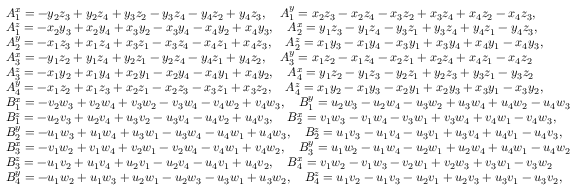Convert formula to latex. <formula><loc_0><loc_0><loc_500><loc_500>\begin{array} { r l } & { A _ { 1 } ^ { x } = - y _ { 2 } z _ { 3 } + y _ { 2 } z _ { 4 } + y _ { 3 } z _ { 2 } - y _ { 3 } z _ { 4 } - y _ { 4 } z _ { 2 } + y _ { 4 } z _ { 3 } , \quad A _ { 1 } ^ { y } = x _ { 2 } z _ { 3 } - x _ { 2 } z _ { 4 } - x _ { 3 } z _ { 2 } + x _ { 3 } z _ { 4 } + x _ { 4 } z _ { 2 } - x _ { 4 } z _ { 3 } , } \\ & { A _ { 1 } ^ { z } = - x _ { 2 } y _ { 3 } + x _ { 2 } y _ { 4 } + x _ { 3 } y _ { 2 } - x _ { 3 } y _ { 4 } - x _ { 4 } y _ { 2 } + x _ { 4 } y _ { 3 } , \quad A _ { 2 } ^ { x } = y _ { 1 } z _ { 3 } - y _ { 1 } z _ { 4 } - y _ { 3 } z _ { 1 } + y _ { 3 } z _ { 4 } + y _ { 4 } z _ { 1 } - y _ { 4 } z _ { 3 } , } \\ & { A _ { 2 } ^ { y } = - x _ { 1 } z _ { 3 } + x _ { 1 } z _ { 4 } + x _ { 3 } z _ { 1 } - x _ { 3 } z _ { 4 } - x _ { 4 } z _ { 1 } + x _ { 4 } z _ { 3 } , \quad A _ { 2 } ^ { z } = x _ { 1 } y _ { 3 } - x _ { 1 } y _ { 4 } - x _ { 3 } y _ { 1 } + x _ { 3 } y _ { 4 } + x _ { 4 } y _ { 1 } - x _ { 4 } y _ { 3 } , } \\ & { A _ { 3 } ^ { x } = - y _ { 1 } z _ { 2 } + y _ { 1 } z _ { 4 } + y _ { 2 } z _ { 1 } - y _ { 2 } z _ { 4 } - y _ { 4 } z _ { 1 } + y _ { 4 } z _ { 2 } , \quad A _ { 3 } ^ { y } = x _ { 1 } z _ { 2 } - x _ { 1 } z _ { 4 } - x _ { 2 } z _ { 1 } + x _ { 2 } z _ { 4 } + x _ { 4 } z _ { 1 } - x _ { 4 } z _ { 2 } } \\ & { A _ { 3 } ^ { z } = - x _ { 1 } y _ { 2 } + x _ { 1 } y _ { 4 } + x _ { 2 } y _ { 1 } - x _ { 2 } y _ { 4 } - x _ { 4 } y _ { 1 } + x _ { 4 } y _ { 2 } , \quad A _ { 4 } ^ { x } = y _ { 1 } z _ { 2 } - y _ { 1 } z _ { 3 } - y _ { 2 } z _ { 1 } + y _ { 2 } z _ { 3 } + y _ { 3 } z _ { 1 } - y _ { 3 } z _ { 2 } } \\ & { A _ { 4 } ^ { y } = - x _ { 1 } z _ { 2 } + x _ { 1 } z _ { 3 } + x _ { 2 } z _ { 1 } - x _ { 2 } z _ { 3 } - x _ { 3 } z _ { 1 } + x _ { 3 } z _ { 2 } , \quad A _ { 4 } ^ { z } = x _ { 1 } y _ { 2 } - x _ { 1 } y _ { 3 } - x _ { 2 } y _ { 1 } + x _ { 2 } y _ { 3 } + x _ { 3 } y _ { 1 } - x _ { 3 } y _ { 2 } , } \\ & { B _ { 1 } ^ { x } = - v _ { 2 } w _ { 3 } + v _ { 2 } w _ { 4 } + v _ { 3 } w _ { 2 } - v _ { 3 } w _ { 4 } - v _ { 4 } w _ { 2 } + v _ { 4 } w _ { 3 } , \quad B _ { 1 } ^ { y } = u _ { 2 } w _ { 3 } - u _ { 2 } w _ { 4 } - u _ { 3 } w _ { 2 } + u _ { 3 } w _ { 4 } + u _ { 4 } w _ { 2 } - u _ { 4 } w _ { 3 } } \\ & { B _ { 1 } ^ { z } = - u _ { 2 } v _ { 3 } + u _ { 2 } v _ { 4 } + u _ { 3 } v _ { 2 } - u _ { 3 } v _ { 4 } - u _ { 4 } v _ { 2 } + u _ { 4 } v _ { 3 } , \quad B _ { 2 } ^ { x } = v _ { 1 } w _ { 3 } - v _ { 1 } w _ { 4 } - v _ { 3 } w _ { 1 } + v _ { 3 } w _ { 4 } + v _ { 4 } w _ { 1 } - v _ { 4 } w _ { 3 } , } \\ & { B _ { 2 } ^ { y } = - u _ { 1 } w _ { 3 } + u _ { 1 } w _ { 4 } + u _ { 3 } w _ { 1 } - u _ { 3 } w _ { 4 } - u _ { 4 } w _ { 1 } + u _ { 4 } w _ { 3 } , \quad B _ { 2 } ^ { z } = u _ { 1 } v _ { 3 } - u _ { 1 } v _ { 4 } - u _ { 3 } v _ { 1 } + u _ { 3 } v _ { 4 } + u _ { 4 } v _ { 1 } - u _ { 4 } v _ { 3 } , } \\ & { B _ { 3 } ^ { x } = - v _ { 1 } w _ { 2 } + v _ { 1 } w _ { 4 } + v _ { 2 } w _ { 1 } - v _ { 2 } w _ { 4 } - v _ { 4 } w _ { 1 } + v _ { 4 } w _ { 2 } , \quad B _ { 3 } ^ { y } = u _ { 1 } w _ { 2 } - u _ { 1 } w _ { 4 } - u _ { 2 } w _ { 1 } + u _ { 2 } w _ { 4 } + u _ { 4 } w _ { 1 } - u _ { 4 } w _ { 2 } } \\ & { B _ { 3 } ^ { z } = - u _ { 1 } v _ { 2 } + u _ { 1 } v _ { 4 } + u _ { 2 } v _ { 1 } - u _ { 2 } v _ { 4 } - u _ { 4 } v _ { 1 } + u _ { 4 } v _ { 2 } , \quad B _ { 4 } ^ { x } = v _ { 1 } w _ { 2 } - v _ { 1 } w _ { 3 } - v _ { 2 } w _ { 1 } + v _ { 2 } w _ { 3 } + v _ { 3 } w _ { 1 } - v _ { 3 } w _ { 2 } } \\ & { B _ { 4 } ^ { y } = - u _ { 1 } w _ { 2 } + u _ { 1 } w _ { 3 } + u _ { 2 } w _ { 1 } - u _ { 2 } w _ { 3 } - u _ { 3 } w _ { 1 } + u _ { 3 } w _ { 2 } , \quad B _ { 4 } ^ { z } = u _ { 1 } v _ { 2 } - u _ { 1 } v _ { 3 } - u _ { 2 } v _ { 1 } + u _ { 2 } v _ { 3 } + u _ { 3 } v _ { 1 } - u _ { 3 } v _ { 2 } , } \end{array}</formula> 